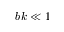Convert formula to latex. <formula><loc_0><loc_0><loc_500><loc_500>b k \ll 1</formula> 